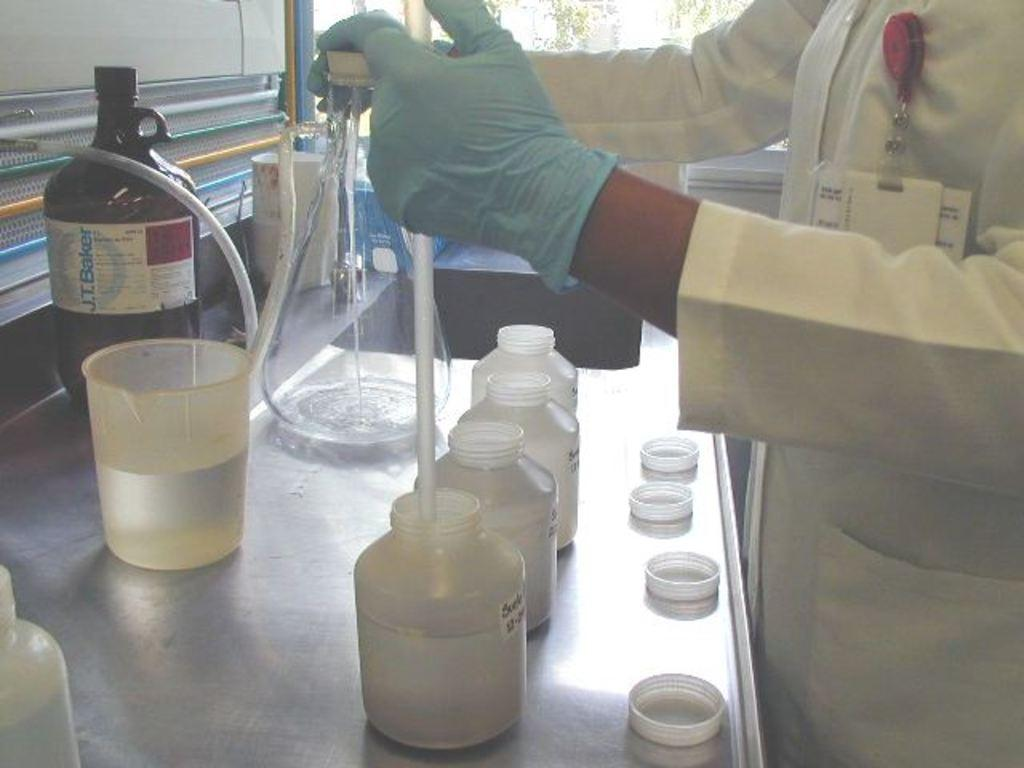<image>
Give a short and clear explanation of the subsequent image. A glass bottle of J.T. Baker is shown 